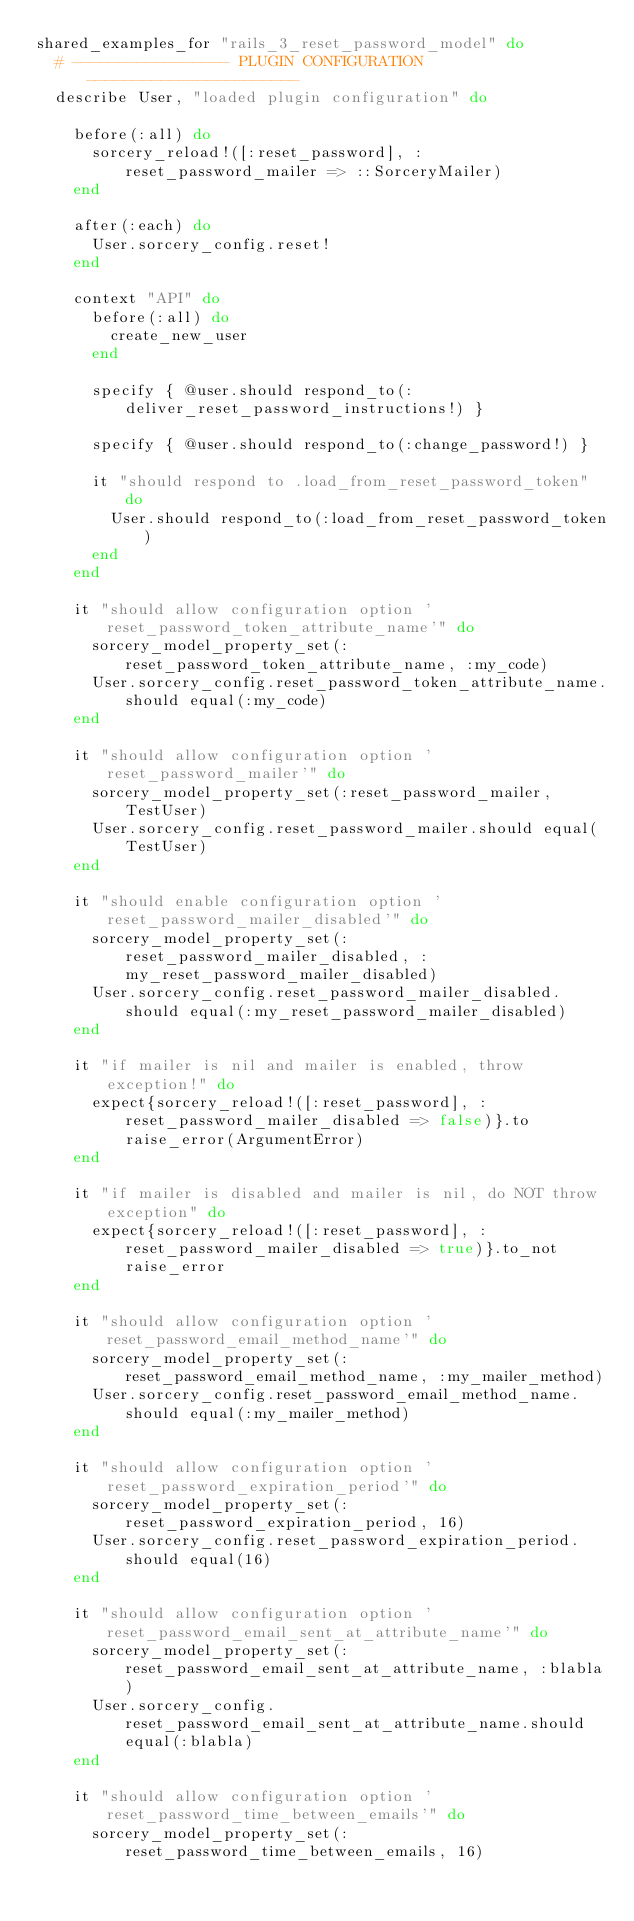<code> <loc_0><loc_0><loc_500><loc_500><_Ruby_>shared_examples_for "rails_3_reset_password_model" do
  # ----------------- PLUGIN CONFIGURATION -----------------------
  describe User, "loaded plugin configuration" do

    before(:all) do
      sorcery_reload!([:reset_password], :reset_password_mailer => ::SorceryMailer)
    end

    after(:each) do
      User.sorcery_config.reset!
    end

    context "API" do
      before(:all) do
        create_new_user
      end

      specify { @user.should respond_to(:deliver_reset_password_instructions!) }

      specify { @user.should respond_to(:change_password!) }

      it "should respond to .load_from_reset_password_token" do
        User.should respond_to(:load_from_reset_password_token)
      end
    end

    it "should allow configuration option 'reset_password_token_attribute_name'" do
      sorcery_model_property_set(:reset_password_token_attribute_name, :my_code)
      User.sorcery_config.reset_password_token_attribute_name.should equal(:my_code)
    end

    it "should allow configuration option 'reset_password_mailer'" do
      sorcery_model_property_set(:reset_password_mailer, TestUser)
      User.sorcery_config.reset_password_mailer.should equal(TestUser)
    end

    it "should enable configuration option 'reset_password_mailer_disabled'" do
      sorcery_model_property_set(:reset_password_mailer_disabled, :my_reset_password_mailer_disabled)
      User.sorcery_config.reset_password_mailer_disabled.should equal(:my_reset_password_mailer_disabled)
    end

    it "if mailer is nil and mailer is enabled, throw exception!" do
      expect{sorcery_reload!([:reset_password], :reset_password_mailer_disabled => false)}.to raise_error(ArgumentError)
    end

    it "if mailer is disabled and mailer is nil, do NOT throw exception" do
      expect{sorcery_reload!([:reset_password], :reset_password_mailer_disabled => true)}.to_not raise_error
    end

    it "should allow configuration option 'reset_password_email_method_name'" do
      sorcery_model_property_set(:reset_password_email_method_name, :my_mailer_method)
      User.sorcery_config.reset_password_email_method_name.should equal(:my_mailer_method)
    end

    it "should allow configuration option 'reset_password_expiration_period'" do
      sorcery_model_property_set(:reset_password_expiration_period, 16)
      User.sorcery_config.reset_password_expiration_period.should equal(16)
    end

    it "should allow configuration option 'reset_password_email_sent_at_attribute_name'" do
      sorcery_model_property_set(:reset_password_email_sent_at_attribute_name, :blabla)
      User.sorcery_config.reset_password_email_sent_at_attribute_name.should equal(:blabla)
    end

    it "should allow configuration option 'reset_password_time_between_emails'" do
      sorcery_model_property_set(:reset_password_time_between_emails, 16)</code> 